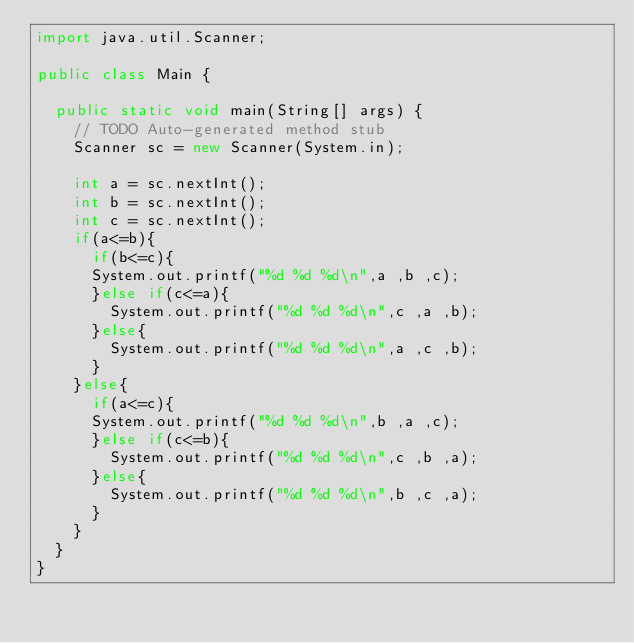Convert code to text. <code><loc_0><loc_0><loc_500><loc_500><_Java_>import java.util.Scanner;

public class Main {

	public static void main(String[] args) {
		// TODO Auto-generated method stub
		Scanner sc = new Scanner(System.in);
		
		int a = sc.nextInt();
		int b = sc.nextInt();		
		int c = sc.nextInt();		
		if(a<=b){
			if(b<=c){
			System.out.printf("%d %d %d\n",a ,b ,c);
			}else if(c<=a){
				System.out.printf("%d %d %d\n",c ,a ,b);
			}else{
				System.out.printf("%d %d %d\n",a ,c ,b);
			}
		}else{
			if(a<=c){
			System.out.printf("%d %d %d\n",b ,a ,c);
			}else if(c<=b){
				System.out.printf("%d %d %d\n",c ,b ,a);
			}else{
				System.out.printf("%d %d %d\n",b ,c ,a);
			}
		}
	}
}</code> 